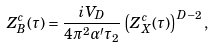<formula> <loc_0><loc_0><loc_500><loc_500>Z _ { B } ^ { c } ( \tau ) = { \frac { i V _ { D } } { 4 \pi ^ { 2 } \alpha ^ { \prime } \tau _ { 2 } } } \left ( Z _ { X } ^ { c } ( \tau ) \right ) ^ { D - 2 } ,</formula> 